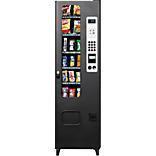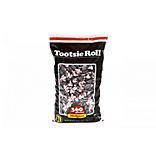The first image is the image on the left, the second image is the image on the right. For the images shown, is this caption "There is at least one vending machine that has three total candy compartments." true? Answer yes or no. No. 